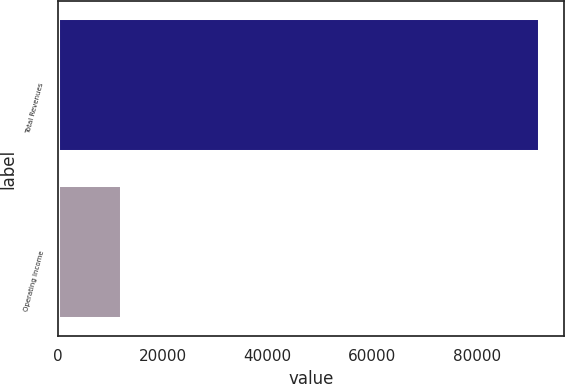Convert chart. <chart><loc_0><loc_0><loc_500><loc_500><bar_chart><fcel>Total Revenues<fcel>Operating Income<nl><fcel>91997<fcel>12159<nl></chart> 